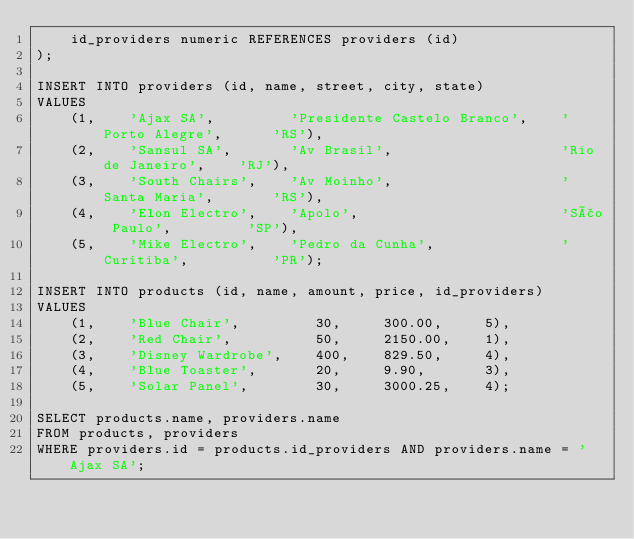<code> <loc_0><loc_0><loc_500><loc_500><_SQL_>    id_providers numeric REFERENCES providers (id)
);

INSERT INTO providers (id, name, street, city, state)
VALUES
    (1,    'Ajax SA',         'Presidente Castelo Branco',    'Porto Alegre',      'RS'),
    (2,    'Sansul SA',       'Av Brasil',                    'Rio de Janeiro',    'RJ'),
    (3,    'South Chairs',    'Av Moinho',                    'Santa Maria',       'RS'),
    (4,    'Elon Electro',    'Apolo',                        'São Paulo',         'SP'),
    (5,    'Mike Electro',    'Pedro da Cunha',               'Curitiba',          'PR');

INSERT INTO products (id, name, amount, price, id_providers)
VALUES
    (1,    'Blue Chair',         30,     300.00,     5),
    (2,    'Red Chair',          50,     2150.00,    1),
    (3,    'Disney Wardrobe',    400,    829.50,     4),
    (4,    'Blue Toaster',       20,     9.90,       3),
    (5,    'Solar Panel',        30,     3000.25,    4);

SELECT products.name, providers.name
FROM products, providers
WHERE providers.id = products.id_providers AND providers.name = 'Ajax SA';</code> 